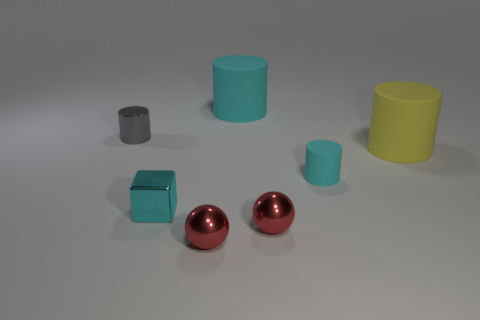Subtract all tiny gray cylinders. How many cylinders are left? 3 Add 1 big yellow shiny things. How many objects exist? 8 Subtract all cyan cylinders. How many cylinders are left? 2 Subtract all blocks. How many objects are left? 6 Subtract 3 cylinders. How many cylinders are left? 1 Subtract all blue blocks. Subtract all purple spheres. How many blocks are left? 1 Subtract all purple spheres. How many cyan cylinders are left? 2 Subtract all cyan cubes. Subtract all small objects. How many objects are left? 1 Add 6 big objects. How many big objects are left? 8 Add 3 small objects. How many small objects exist? 8 